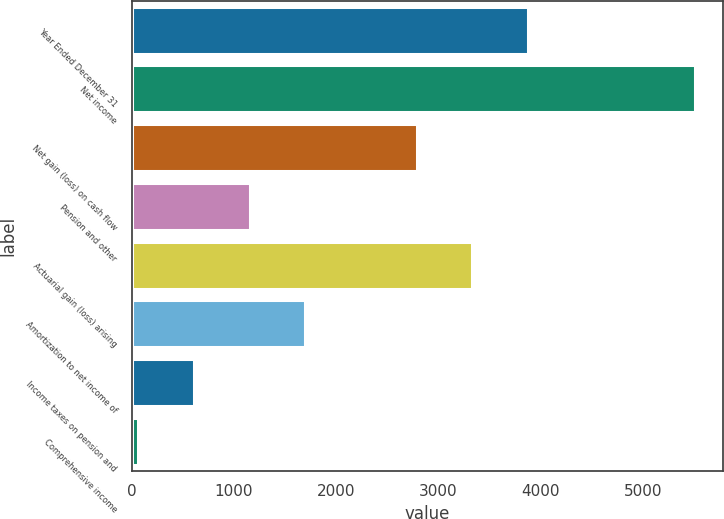<chart> <loc_0><loc_0><loc_500><loc_500><bar_chart><fcel>Year Ended December 31<fcel>Net income<fcel>Net gain (loss) on cash flow<fcel>Pension and other<fcel>Actuarial gain (loss) arising<fcel>Amortization to net income of<fcel>Income taxes on pension and<fcel>Comprehensive income<nl><fcel>3874.6<fcel>5506<fcel>2787<fcel>1155.6<fcel>3330.8<fcel>1699.4<fcel>611.8<fcel>68<nl></chart> 